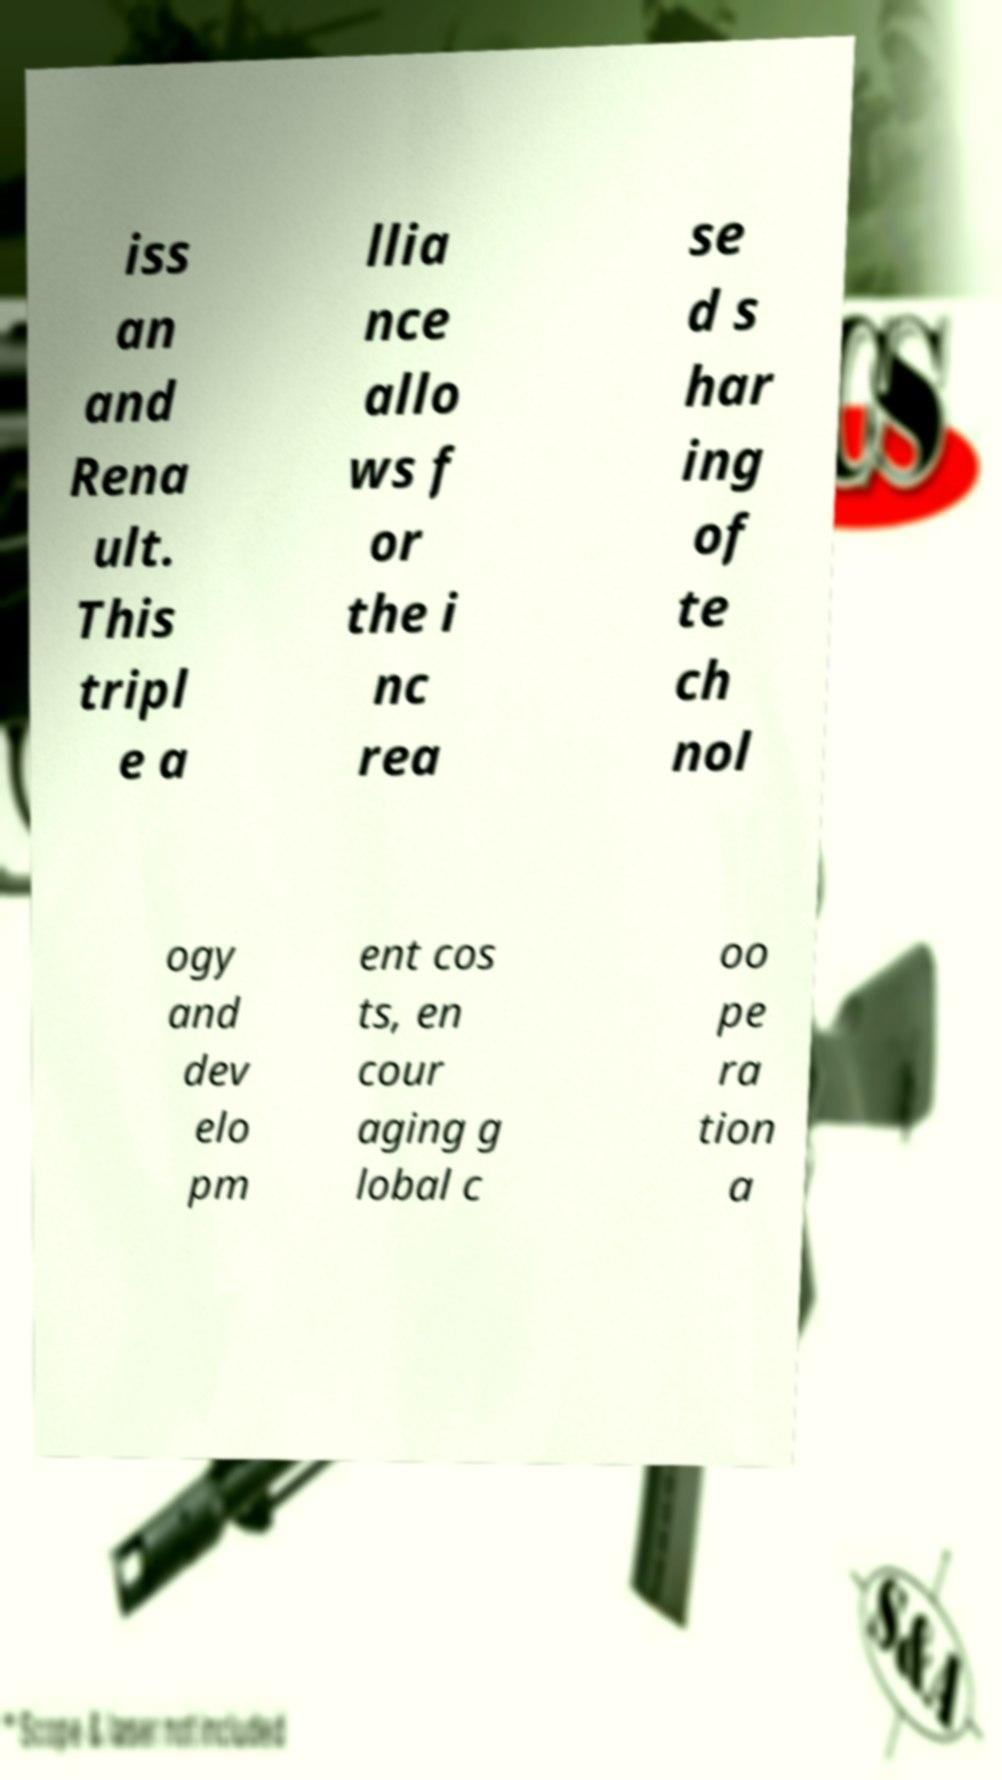Could you assist in decoding the text presented in this image and type it out clearly? iss an and Rena ult. This tripl e a llia nce allo ws f or the i nc rea se d s har ing of te ch nol ogy and dev elo pm ent cos ts, en cour aging g lobal c oo pe ra tion a 